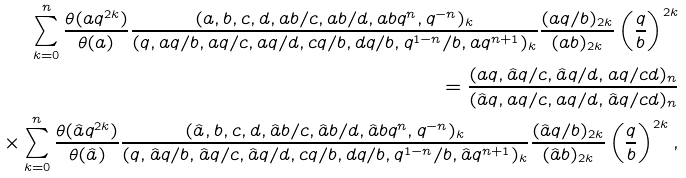<formula> <loc_0><loc_0><loc_500><loc_500>\sum _ { k = 0 } ^ { n } \frac { \theta ( a q ^ { 2 k } ) } { \theta ( a ) } \frac { ( a , b , c , d , a b / c , a b / d , a b q ^ { n } , q ^ { - n } ) _ { k } } { ( q , a q / b , a q / c , a q / d , c q / b , d q / b , q ^ { 1 - n } / b , a q ^ { n + 1 } ) _ { k } } \frac { ( a q / b ) _ { 2 k } } { ( a b ) _ { 2 k } } \left ( \frac { q } { b } \right ) ^ { 2 k } \\ = \frac { ( a q , \hat { a } q / c , \hat { a } q / d , a q / c d ) _ { n } } { ( \hat { a } q , a q / c , a q / d , \hat { a } q / c d ) _ { n } } \\ \quad \times \sum _ { k = 0 } ^ { n } \frac { \theta ( \hat { a } q ^ { 2 k } ) } { \theta ( \hat { a } ) } \frac { ( \hat { a } , b , c , d , \hat { a } b / c , \hat { a } b / d , \hat { a } b q ^ { n } , q ^ { - n } ) _ { k } } { ( q , \hat { a } q / b , \hat { a } q / c , \hat { a } q / d , c q / b , d q / b , q ^ { 1 - n } / b , \hat { a } q ^ { n + 1 } ) _ { k } } \frac { ( \hat { a } q / b ) _ { 2 k } } { ( \hat { a } b ) _ { 2 k } } \left ( \frac { q } { b } \right ) ^ { 2 k } ,</formula> 